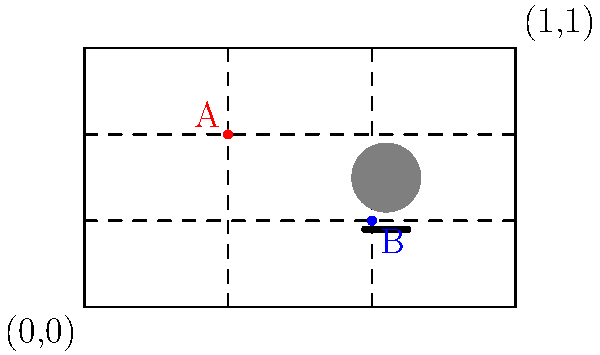In the anime scene composition above, points A and B represent key elements in the frame. Using a relative coordinate system where (0,0) is the bottom-left corner and (1,1) is the top-right corner, what are the coordinates of points A and B? To find the coordinates of points A and B in the relative coordinate system:

1. Identify the rule-of-thirds grid:
   - The grid divides the frame into 3x3 equal sections.

2. Locate points A and B:
   - Point A (red) is at the intersection of the left vertical and upper horizontal lines.
   - Point B (blue) is at the intersection of the right vertical and lower horizontal lines.

3. Convert to relative coordinates:
   - In a 3x3 grid, the intersections occur at 1/3 and 2/3 of each dimension.
   - The x-coordinate of the left vertical line is 1/3, and the right is 2/3.
   - The y-coordinate of the lower horizontal line is 1/3, and the upper is 2/3.

4. Determine the coordinates:
   - Point A: x = 1/3, y = 2/3
   - Point B: x = 2/3, y = 1/3

5. Express as ordered pairs:
   - A = (1/3, 2/3)
   - B = (2/3, 1/3)
Answer: A(1/3, 2/3), B(2/3, 1/3) 